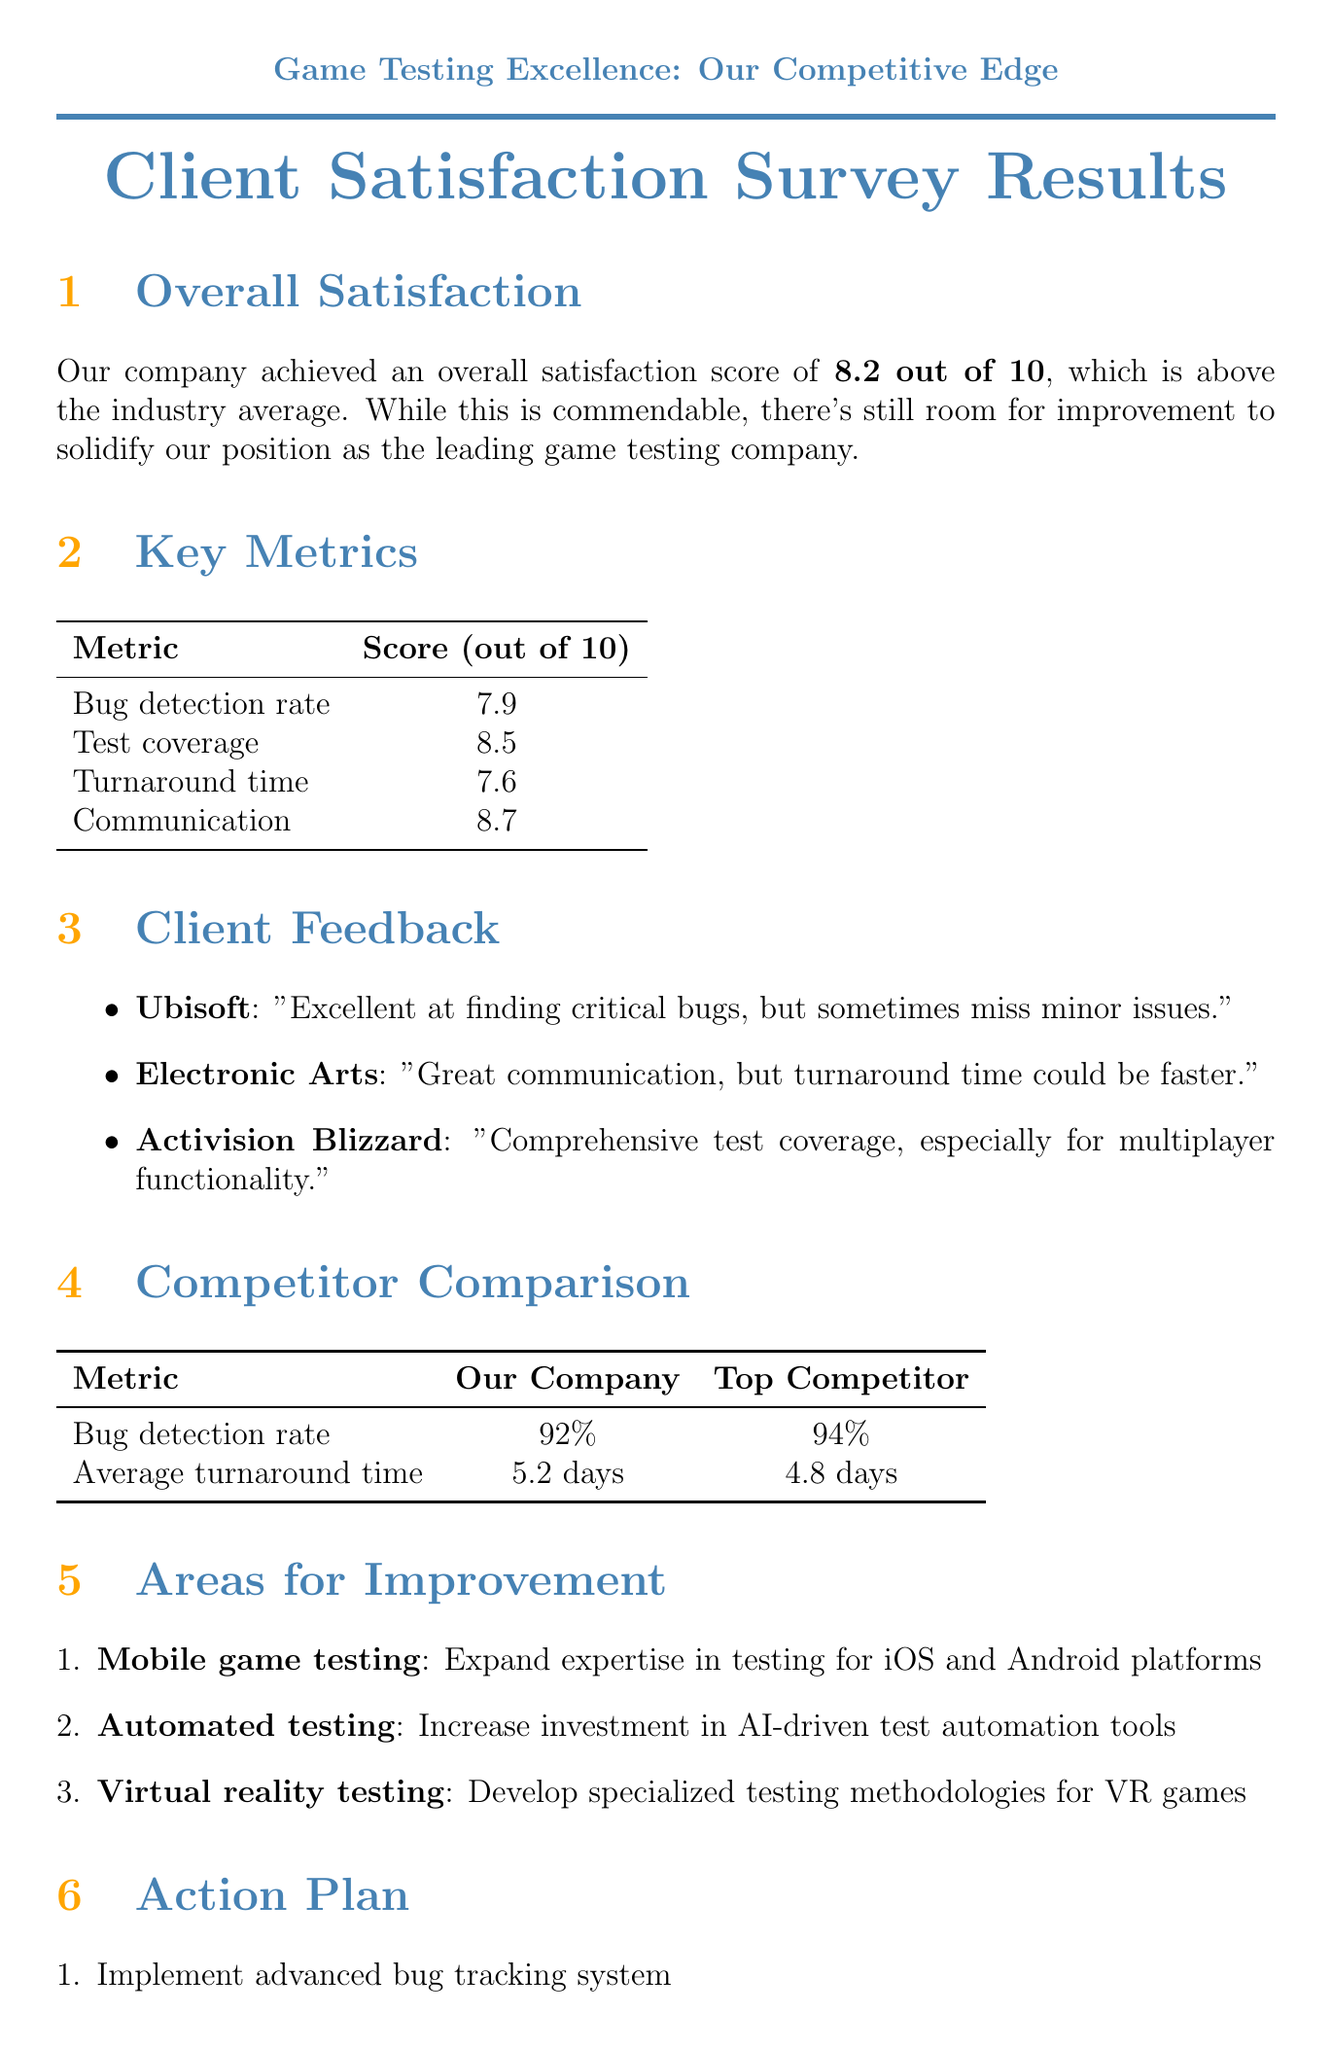What is the overall satisfaction score? The overall satisfaction score is explicitly stated in the document as 8.2 out of 10.
Answer: 8.2 out of 10 Which client reported great communication? The document lists comments from various clients; specifically, Electronic Arts mentioned great communication.
Answer: Electronic Arts What is the goal for reducing turnaround time? The document outlines an action plan which states the goal is to reduce turnaround time by 15% within 3 months.
Answer: Reduce turnaround time by 15% within 3 months What percentage is our company's bug detection rate compared to the industry average? The document states that our company has a bug detection rate of 92%, while the industry average is 88%.
Answer: 92% What area for improvement involves specialized methodologies? The document highlights the need for specialized testing methodologies in the area of Virtual reality testing.
Answer: Virtual reality testing What is a future goal set for Q1 2024? The document mentions the goal to develop proprietary AI-assisted testing software is set for Q1 2024.
Answer: Develop proprietary AI-assisted testing software Which client provided a testimonial about multiplayer game testing? Riot Games provided a testimonial specifically praising expertise in multiplayer game testing.
Answer: Riot Games How much should automated test coverage increase by? The action plan specifies an increase in automated test coverage by 20% within 8 months.
Answer: Increase automated test coverage by 20% within 8 months 